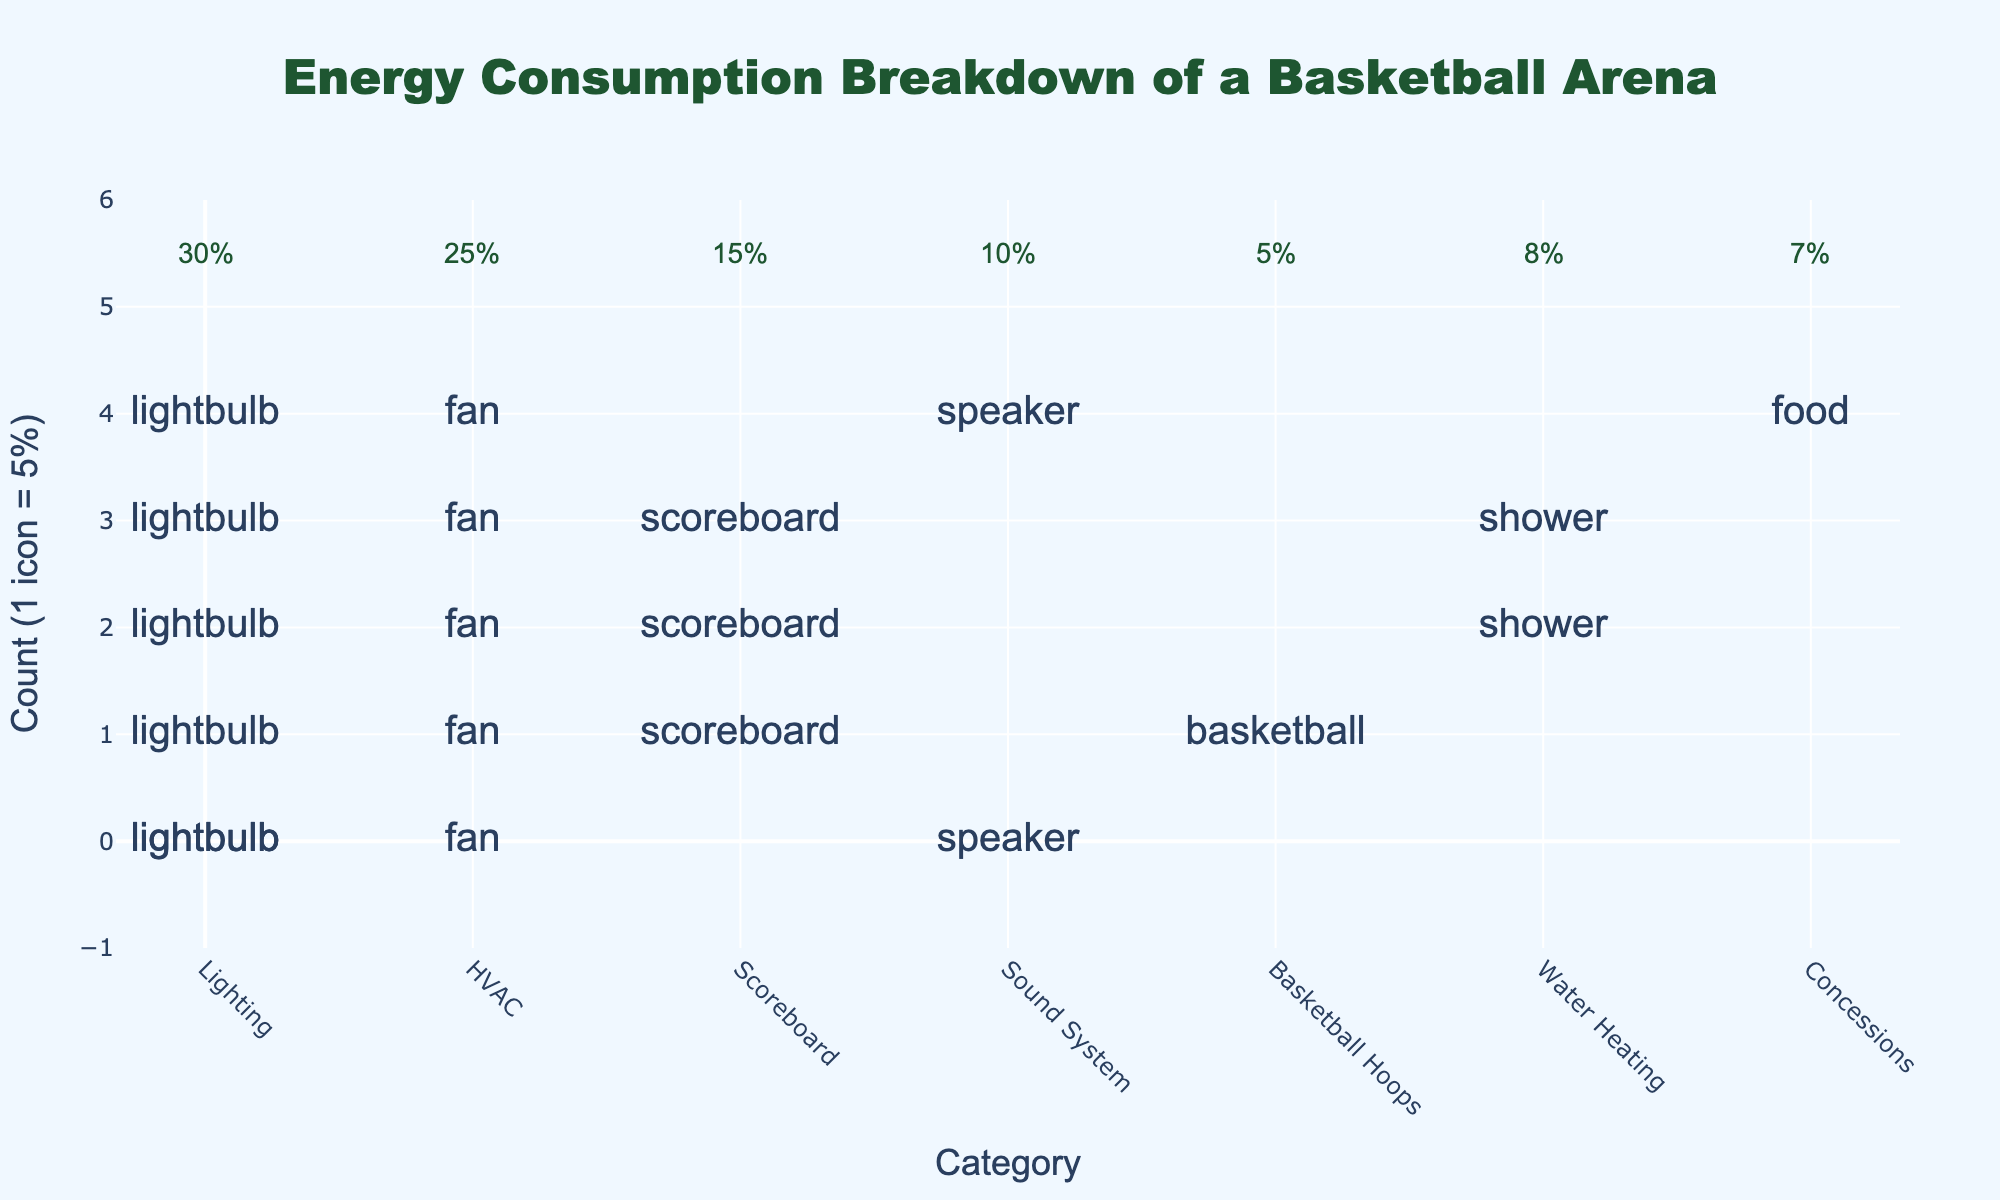What's the title of the figure? The title is indicated at the top center of the plot.
Answer: Energy Consumption Breakdown of a Basketball Arena What categories have the smallest energy consumption? By looking at the number of icons and their placement, we identify that Basketball Hoops, Concessions, and Water Heating have fewer icons compared to others.
Answer: Basketball Hoops, Concessions, Water Heating How many lightbulb icons are there in the plot? We observe the number of lightbulb icons along the x-axis labeled 'Lighting', each icon representing 5%. There are 6 icons.
Answer: 6 Which category has the second highest energy consumption? By counting the number of icons per category, we see that Lighting has the highest and HVAC has the second highest number of icons.
Answer: HVAC How much more energy does Lighting consume compared to Water Heating? Lighting has 6 icons (30%) and Water Heating has 2 icons (8%). The difference is 30% - 8%.
Answer: 22% What is the combined energy consumption percentage for Scoreboard and Sound System? Scoreboard has 3 icons (15%) and Sound System has 2 icons (10%). Adding these gives 15% + 10%.
Answer: 25% How does the energy consumption of Sound System compare to Concessions? Sound System has 2 icons (10%) while Concessions has 1 icon (7%). Sound System consumes 3% more energy.
Answer: 3% Which category has the least number of icons? By counting the icons, we observe that Basketball Hoops has the least number with 1 icon (5%).
Answer: Basketball Hoops What proportion of the energy is used by HVAC and Lighting combined? HVAC has 5 icons (25%) and Lighting has 6 icons (30%). Together, they consume 25% + 30%.
Answer: 55% Is Water Heating's energy consumption greater than Basketball Hoops'? Water Heating has 2 icons (8%) while Basketball Hoops has 1 icon (5%). Since 8% is greater than 5%, the answer is yes.
Answer: Yes 